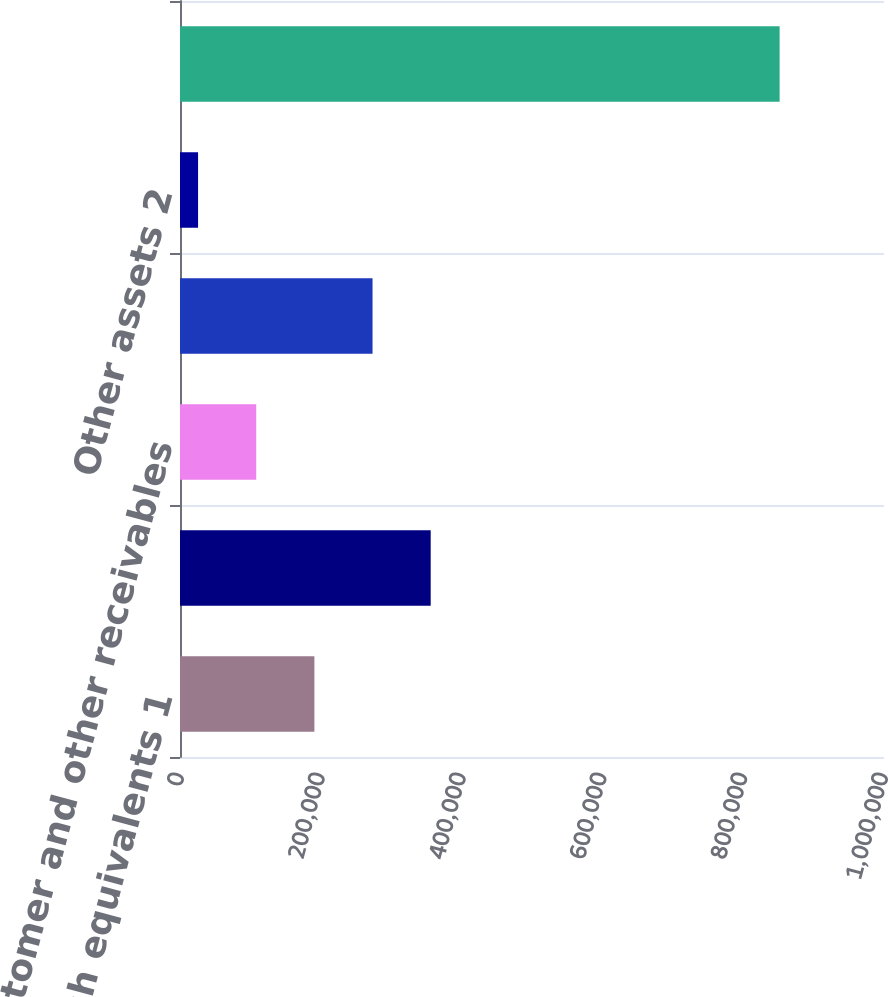<chart> <loc_0><loc_0><loc_500><loc_500><bar_chart><fcel>Cash and cash equivalents 1<fcel>Trading assets at fair value<fcel>Customer and other receivables<fcel>Loans net of allowance<fcel>Other assets 2<fcel>Total assets<nl><fcel>190885<fcel>356097<fcel>108279<fcel>273491<fcel>25673<fcel>851733<nl></chart> 